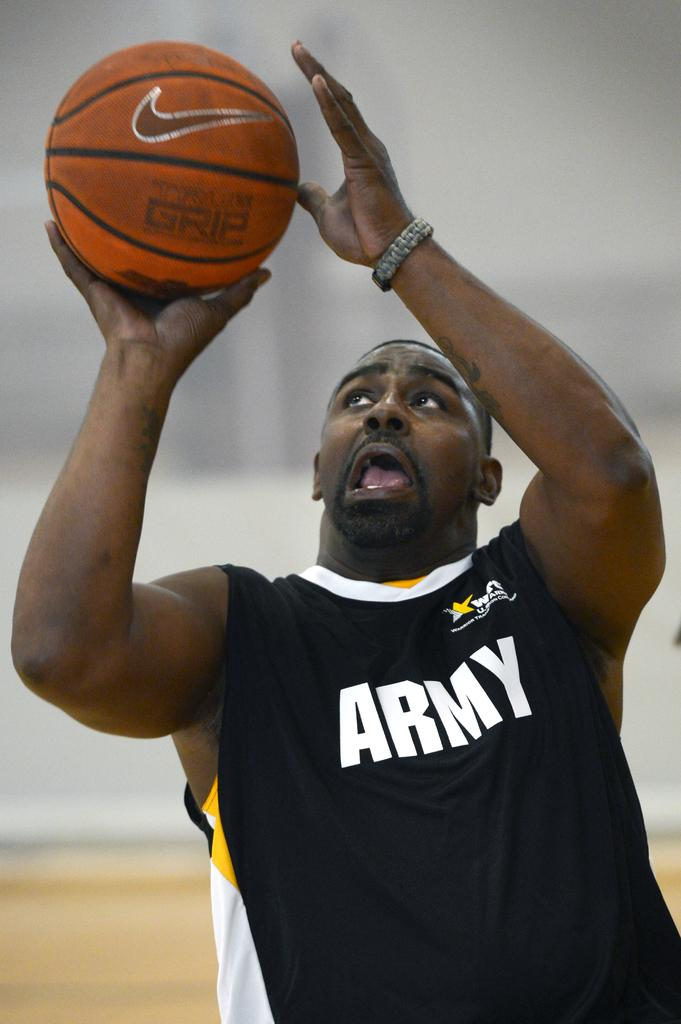Provide a one-sentence caption for the provided image. A basketball player wearing a top that says "ARMY", looking up with a ball in his right hand. 